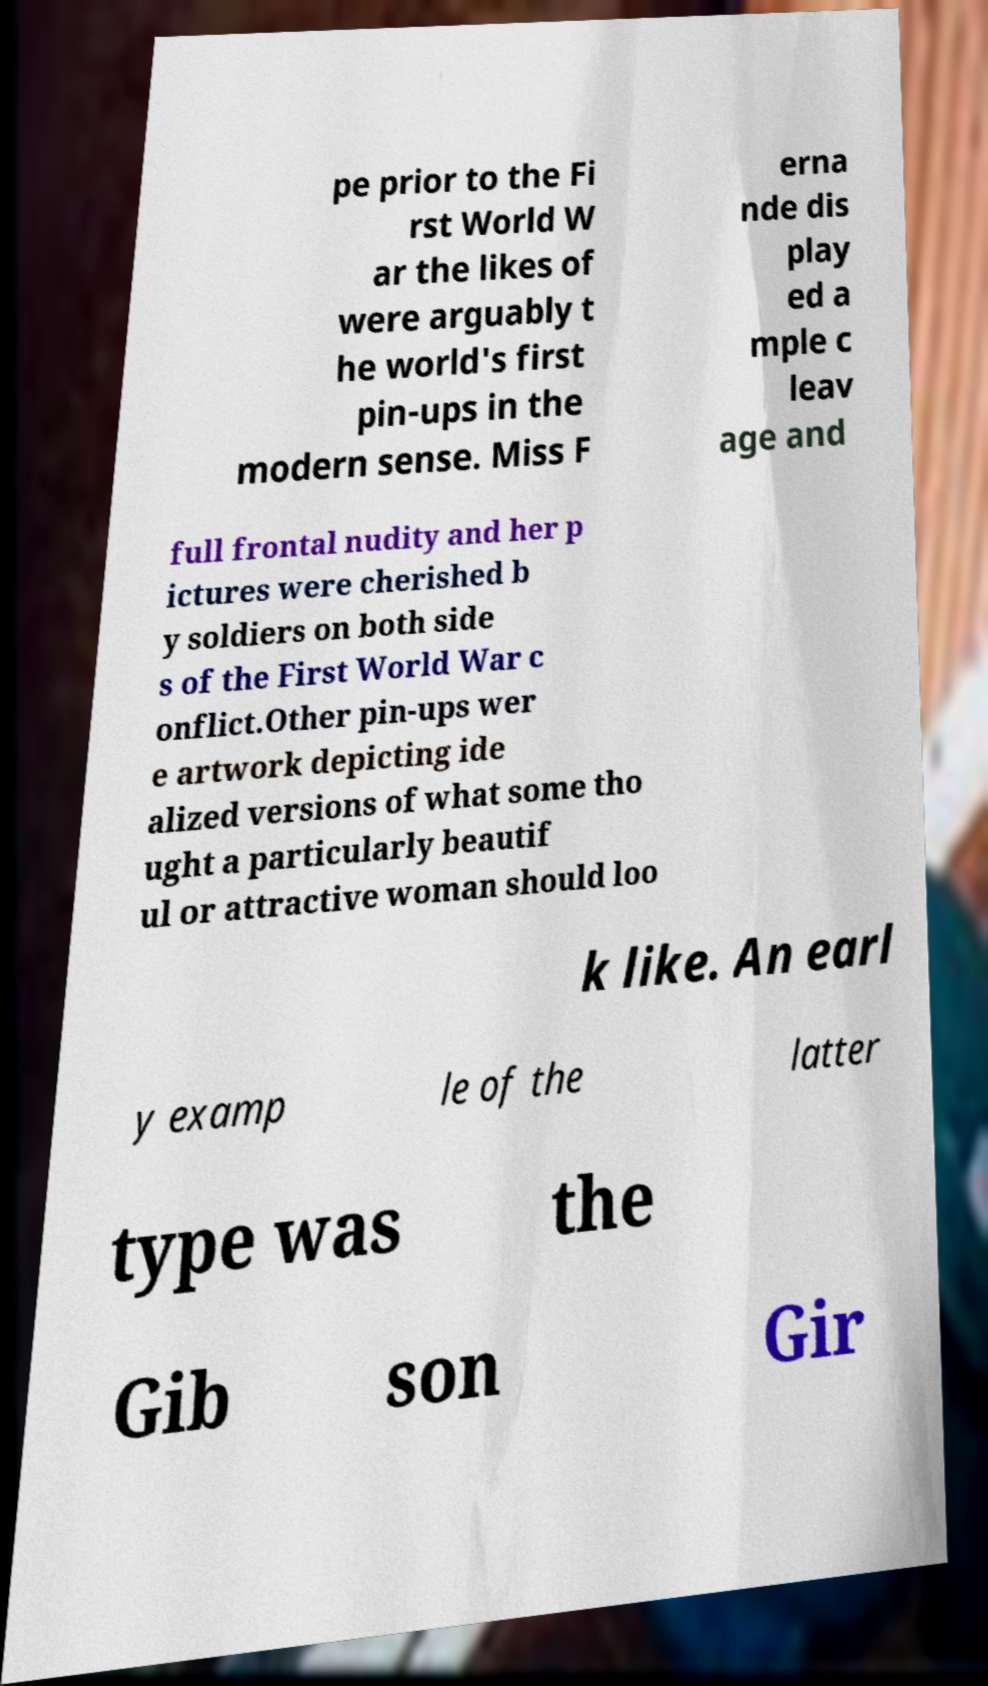Can you accurately transcribe the text from the provided image for me? pe prior to the Fi rst World W ar the likes of were arguably t he world's first pin-ups in the modern sense. Miss F erna nde dis play ed a mple c leav age and full frontal nudity and her p ictures were cherished b y soldiers on both side s of the First World War c onflict.Other pin-ups wer e artwork depicting ide alized versions of what some tho ught a particularly beautif ul or attractive woman should loo k like. An earl y examp le of the latter type was the Gib son Gir 